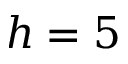<formula> <loc_0><loc_0><loc_500><loc_500>h = 5</formula> 